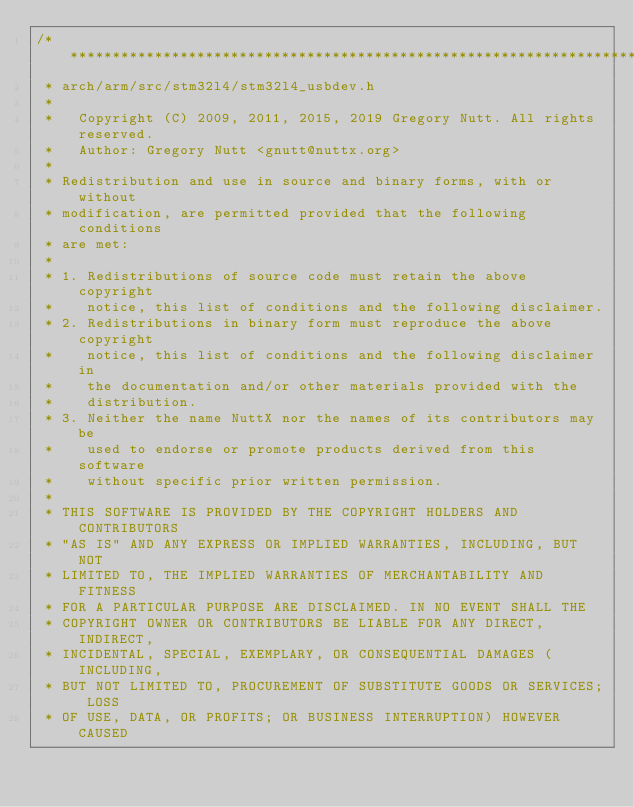<code> <loc_0><loc_0><loc_500><loc_500><_C_>/************************************************************************************
 * arch/arm/src/stm32l4/stm32l4_usbdev.h
 *
 *   Copyright (C) 2009, 2011, 2015, 2019 Gregory Nutt. All rights reserved.
 *   Author: Gregory Nutt <gnutt@nuttx.org>
 *
 * Redistribution and use in source and binary forms, with or without
 * modification, are permitted provided that the following conditions
 * are met:
 *
 * 1. Redistributions of source code must retain the above copyright
 *    notice, this list of conditions and the following disclaimer.
 * 2. Redistributions in binary form must reproduce the above copyright
 *    notice, this list of conditions and the following disclaimer in
 *    the documentation and/or other materials provided with the
 *    distribution.
 * 3. Neither the name NuttX nor the names of its contributors may be
 *    used to endorse or promote products derived from this software
 *    without specific prior written permission.
 *
 * THIS SOFTWARE IS PROVIDED BY THE COPYRIGHT HOLDERS AND CONTRIBUTORS
 * "AS IS" AND ANY EXPRESS OR IMPLIED WARRANTIES, INCLUDING, BUT NOT
 * LIMITED TO, THE IMPLIED WARRANTIES OF MERCHANTABILITY AND FITNESS
 * FOR A PARTICULAR PURPOSE ARE DISCLAIMED. IN NO EVENT SHALL THE
 * COPYRIGHT OWNER OR CONTRIBUTORS BE LIABLE FOR ANY DIRECT, INDIRECT,
 * INCIDENTAL, SPECIAL, EXEMPLARY, OR CONSEQUENTIAL DAMAGES (INCLUDING,
 * BUT NOT LIMITED TO, PROCUREMENT OF SUBSTITUTE GOODS OR SERVICES; LOSS
 * OF USE, DATA, OR PROFITS; OR BUSINESS INTERRUPTION) HOWEVER CAUSED</code> 